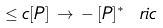Convert formula to latex. <formula><loc_0><loc_0><loc_500><loc_500>\leq c [ P ] \, \rightarrow \, - \, [ P ] ^ { \ast } \ r i c \,</formula> 